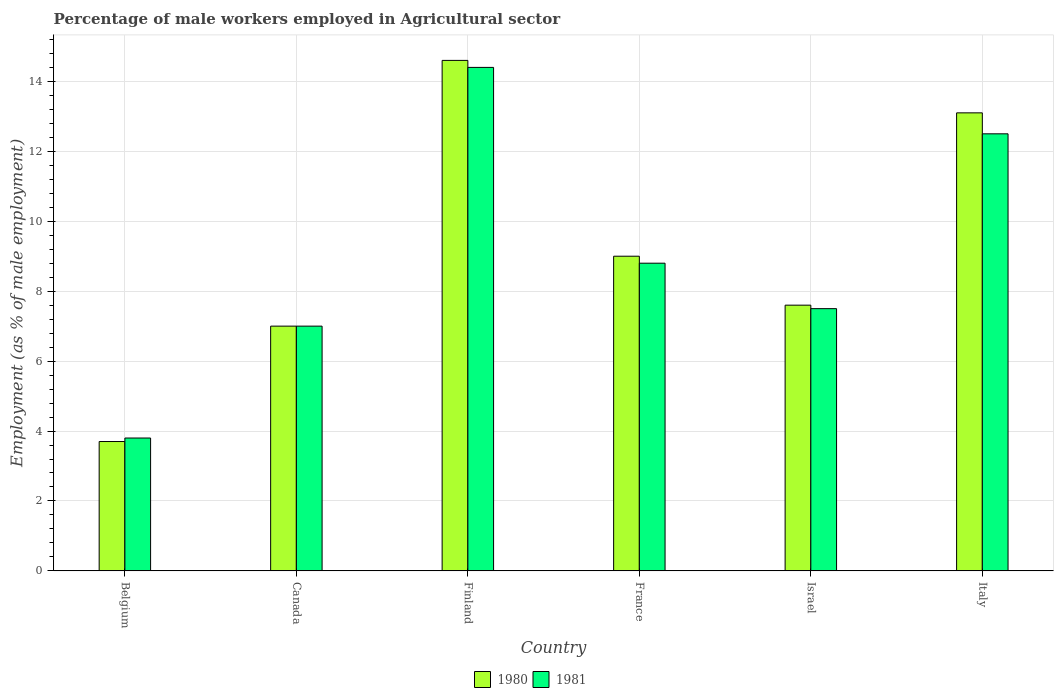How many groups of bars are there?
Make the answer very short. 6. How many bars are there on the 1st tick from the right?
Offer a very short reply. 2. In how many cases, is the number of bars for a given country not equal to the number of legend labels?
Your response must be concise. 0. What is the percentage of male workers employed in Agricultural sector in 1981 in France?
Offer a terse response. 8.8. Across all countries, what is the maximum percentage of male workers employed in Agricultural sector in 1981?
Give a very brief answer. 14.4. Across all countries, what is the minimum percentage of male workers employed in Agricultural sector in 1980?
Your answer should be very brief. 3.7. In which country was the percentage of male workers employed in Agricultural sector in 1980 maximum?
Offer a terse response. Finland. What is the total percentage of male workers employed in Agricultural sector in 1981 in the graph?
Your response must be concise. 54. What is the difference between the percentage of male workers employed in Agricultural sector in 1980 in Finland and that in France?
Provide a short and direct response. 5.6. What is the difference between the percentage of male workers employed in Agricultural sector in 1981 in Israel and the percentage of male workers employed in Agricultural sector in 1980 in Italy?
Provide a succinct answer. -5.6. What is the average percentage of male workers employed in Agricultural sector in 1980 per country?
Ensure brevity in your answer.  9.17. What is the difference between the percentage of male workers employed in Agricultural sector of/in 1980 and percentage of male workers employed in Agricultural sector of/in 1981 in Belgium?
Ensure brevity in your answer.  -0.1. What is the ratio of the percentage of male workers employed in Agricultural sector in 1981 in France to that in Israel?
Ensure brevity in your answer.  1.17. What is the difference between the highest and the second highest percentage of male workers employed in Agricultural sector in 1980?
Offer a very short reply. -4.1. What is the difference between the highest and the lowest percentage of male workers employed in Agricultural sector in 1981?
Make the answer very short. 10.6. Is the sum of the percentage of male workers employed in Agricultural sector in 1980 in Belgium and France greater than the maximum percentage of male workers employed in Agricultural sector in 1981 across all countries?
Keep it short and to the point. No. What does the 2nd bar from the right in France represents?
Your answer should be very brief. 1980. How many bars are there?
Your answer should be compact. 12. Are all the bars in the graph horizontal?
Offer a very short reply. No. How many countries are there in the graph?
Keep it short and to the point. 6. Are the values on the major ticks of Y-axis written in scientific E-notation?
Provide a succinct answer. No. Where does the legend appear in the graph?
Provide a short and direct response. Bottom center. How many legend labels are there?
Provide a short and direct response. 2. How are the legend labels stacked?
Provide a short and direct response. Horizontal. What is the title of the graph?
Make the answer very short. Percentage of male workers employed in Agricultural sector. Does "1998" appear as one of the legend labels in the graph?
Make the answer very short. No. What is the label or title of the Y-axis?
Your answer should be very brief. Employment (as % of male employment). What is the Employment (as % of male employment) of 1980 in Belgium?
Offer a very short reply. 3.7. What is the Employment (as % of male employment) of 1981 in Belgium?
Your answer should be compact. 3.8. What is the Employment (as % of male employment) of 1981 in Canada?
Keep it short and to the point. 7. What is the Employment (as % of male employment) in 1980 in Finland?
Your answer should be very brief. 14.6. What is the Employment (as % of male employment) in 1981 in Finland?
Your answer should be very brief. 14.4. What is the Employment (as % of male employment) in 1981 in France?
Keep it short and to the point. 8.8. What is the Employment (as % of male employment) in 1980 in Israel?
Offer a terse response. 7.6. What is the Employment (as % of male employment) in 1981 in Israel?
Offer a very short reply. 7.5. What is the Employment (as % of male employment) in 1980 in Italy?
Your response must be concise. 13.1. What is the Employment (as % of male employment) of 1981 in Italy?
Offer a terse response. 12.5. Across all countries, what is the maximum Employment (as % of male employment) in 1980?
Your answer should be very brief. 14.6. Across all countries, what is the maximum Employment (as % of male employment) in 1981?
Offer a terse response. 14.4. Across all countries, what is the minimum Employment (as % of male employment) in 1980?
Your response must be concise. 3.7. Across all countries, what is the minimum Employment (as % of male employment) of 1981?
Offer a very short reply. 3.8. What is the total Employment (as % of male employment) of 1980 in the graph?
Give a very brief answer. 55. What is the total Employment (as % of male employment) of 1981 in the graph?
Offer a very short reply. 54. What is the difference between the Employment (as % of male employment) of 1981 in Belgium and that in Canada?
Make the answer very short. -3.2. What is the difference between the Employment (as % of male employment) in 1980 in Belgium and that in Finland?
Offer a very short reply. -10.9. What is the difference between the Employment (as % of male employment) in 1981 in Belgium and that in Finland?
Your answer should be compact. -10.6. What is the difference between the Employment (as % of male employment) of 1980 in Belgium and that in France?
Offer a very short reply. -5.3. What is the difference between the Employment (as % of male employment) of 1981 in Belgium and that in France?
Give a very brief answer. -5. What is the difference between the Employment (as % of male employment) in 1980 in Belgium and that in Israel?
Ensure brevity in your answer.  -3.9. What is the difference between the Employment (as % of male employment) in 1980 in Belgium and that in Italy?
Offer a very short reply. -9.4. What is the difference between the Employment (as % of male employment) in 1981 in Belgium and that in Italy?
Your answer should be very brief. -8.7. What is the difference between the Employment (as % of male employment) of 1980 in Canada and that in Finland?
Provide a short and direct response. -7.6. What is the difference between the Employment (as % of male employment) in 1980 in Canada and that in France?
Keep it short and to the point. -2. What is the difference between the Employment (as % of male employment) in 1981 in Canada and that in France?
Your answer should be very brief. -1.8. What is the difference between the Employment (as % of male employment) in 1980 in Canada and that in Israel?
Offer a very short reply. -0.6. What is the difference between the Employment (as % of male employment) of 1981 in Canada and that in Israel?
Offer a very short reply. -0.5. What is the difference between the Employment (as % of male employment) in 1980 in Canada and that in Italy?
Offer a terse response. -6.1. What is the difference between the Employment (as % of male employment) of 1980 in Finland and that in France?
Provide a succinct answer. 5.6. What is the difference between the Employment (as % of male employment) of 1981 in Finland and that in France?
Give a very brief answer. 5.6. What is the difference between the Employment (as % of male employment) of 1980 in Finland and that in Israel?
Make the answer very short. 7. What is the difference between the Employment (as % of male employment) of 1981 in Finland and that in Israel?
Your answer should be compact. 6.9. What is the difference between the Employment (as % of male employment) in 1980 in France and that in Italy?
Ensure brevity in your answer.  -4.1. What is the difference between the Employment (as % of male employment) in 1980 in Israel and that in Italy?
Your response must be concise. -5.5. What is the difference between the Employment (as % of male employment) in 1980 in Belgium and the Employment (as % of male employment) in 1981 in Canada?
Your response must be concise. -3.3. What is the difference between the Employment (as % of male employment) in 1980 in Belgium and the Employment (as % of male employment) in 1981 in Italy?
Provide a succinct answer. -8.8. What is the difference between the Employment (as % of male employment) of 1980 in Canada and the Employment (as % of male employment) of 1981 in Finland?
Offer a terse response. -7.4. What is the difference between the Employment (as % of male employment) in 1980 in Canada and the Employment (as % of male employment) in 1981 in Israel?
Give a very brief answer. -0.5. What is the difference between the Employment (as % of male employment) of 1980 in Finland and the Employment (as % of male employment) of 1981 in Italy?
Offer a very short reply. 2.1. What is the difference between the Employment (as % of male employment) of 1980 in France and the Employment (as % of male employment) of 1981 in Israel?
Make the answer very short. 1.5. What is the average Employment (as % of male employment) in 1980 per country?
Give a very brief answer. 9.17. What is the difference between the Employment (as % of male employment) of 1980 and Employment (as % of male employment) of 1981 in Belgium?
Give a very brief answer. -0.1. What is the difference between the Employment (as % of male employment) of 1980 and Employment (as % of male employment) of 1981 in France?
Your response must be concise. 0.2. What is the difference between the Employment (as % of male employment) of 1980 and Employment (as % of male employment) of 1981 in Israel?
Give a very brief answer. 0.1. What is the difference between the Employment (as % of male employment) of 1980 and Employment (as % of male employment) of 1981 in Italy?
Provide a succinct answer. 0.6. What is the ratio of the Employment (as % of male employment) of 1980 in Belgium to that in Canada?
Keep it short and to the point. 0.53. What is the ratio of the Employment (as % of male employment) of 1981 in Belgium to that in Canada?
Ensure brevity in your answer.  0.54. What is the ratio of the Employment (as % of male employment) of 1980 in Belgium to that in Finland?
Offer a very short reply. 0.25. What is the ratio of the Employment (as % of male employment) of 1981 in Belgium to that in Finland?
Offer a very short reply. 0.26. What is the ratio of the Employment (as % of male employment) of 1980 in Belgium to that in France?
Provide a short and direct response. 0.41. What is the ratio of the Employment (as % of male employment) in 1981 in Belgium to that in France?
Your answer should be compact. 0.43. What is the ratio of the Employment (as % of male employment) of 1980 in Belgium to that in Israel?
Your response must be concise. 0.49. What is the ratio of the Employment (as % of male employment) of 1981 in Belgium to that in Israel?
Provide a succinct answer. 0.51. What is the ratio of the Employment (as % of male employment) in 1980 in Belgium to that in Italy?
Your answer should be compact. 0.28. What is the ratio of the Employment (as % of male employment) of 1981 in Belgium to that in Italy?
Provide a short and direct response. 0.3. What is the ratio of the Employment (as % of male employment) in 1980 in Canada to that in Finland?
Your answer should be very brief. 0.48. What is the ratio of the Employment (as % of male employment) in 1981 in Canada to that in Finland?
Your response must be concise. 0.49. What is the ratio of the Employment (as % of male employment) in 1981 in Canada to that in France?
Ensure brevity in your answer.  0.8. What is the ratio of the Employment (as % of male employment) of 1980 in Canada to that in Israel?
Your response must be concise. 0.92. What is the ratio of the Employment (as % of male employment) of 1981 in Canada to that in Israel?
Offer a terse response. 0.93. What is the ratio of the Employment (as % of male employment) of 1980 in Canada to that in Italy?
Your response must be concise. 0.53. What is the ratio of the Employment (as % of male employment) in 1981 in Canada to that in Italy?
Offer a terse response. 0.56. What is the ratio of the Employment (as % of male employment) of 1980 in Finland to that in France?
Give a very brief answer. 1.62. What is the ratio of the Employment (as % of male employment) of 1981 in Finland to that in France?
Offer a very short reply. 1.64. What is the ratio of the Employment (as % of male employment) of 1980 in Finland to that in Israel?
Give a very brief answer. 1.92. What is the ratio of the Employment (as % of male employment) in 1981 in Finland to that in Israel?
Make the answer very short. 1.92. What is the ratio of the Employment (as % of male employment) of 1980 in Finland to that in Italy?
Your answer should be compact. 1.11. What is the ratio of the Employment (as % of male employment) of 1981 in Finland to that in Italy?
Your answer should be compact. 1.15. What is the ratio of the Employment (as % of male employment) of 1980 in France to that in Israel?
Keep it short and to the point. 1.18. What is the ratio of the Employment (as % of male employment) of 1981 in France to that in Israel?
Provide a short and direct response. 1.17. What is the ratio of the Employment (as % of male employment) of 1980 in France to that in Italy?
Your answer should be very brief. 0.69. What is the ratio of the Employment (as % of male employment) in 1981 in France to that in Italy?
Provide a short and direct response. 0.7. What is the ratio of the Employment (as % of male employment) of 1980 in Israel to that in Italy?
Your answer should be very brief. 0.58. What is the ratio of the Employment (as % of male employment) of 1981 in Israel to that in Italy?
Offer a very short reply. 0.6. What is the difference between the highest and the second highest Employment (as % of male employment) in 1980?
Your response must be concise. 1.5. What is the difference between the highest and the lowest Employment (as % of male employment) of 1980?
Provide a short and direct response. 10.9. What is the difference between the highest and the lowest Employment (as % of male employment) in 1981?
Offer a very short reply. 10.6. 